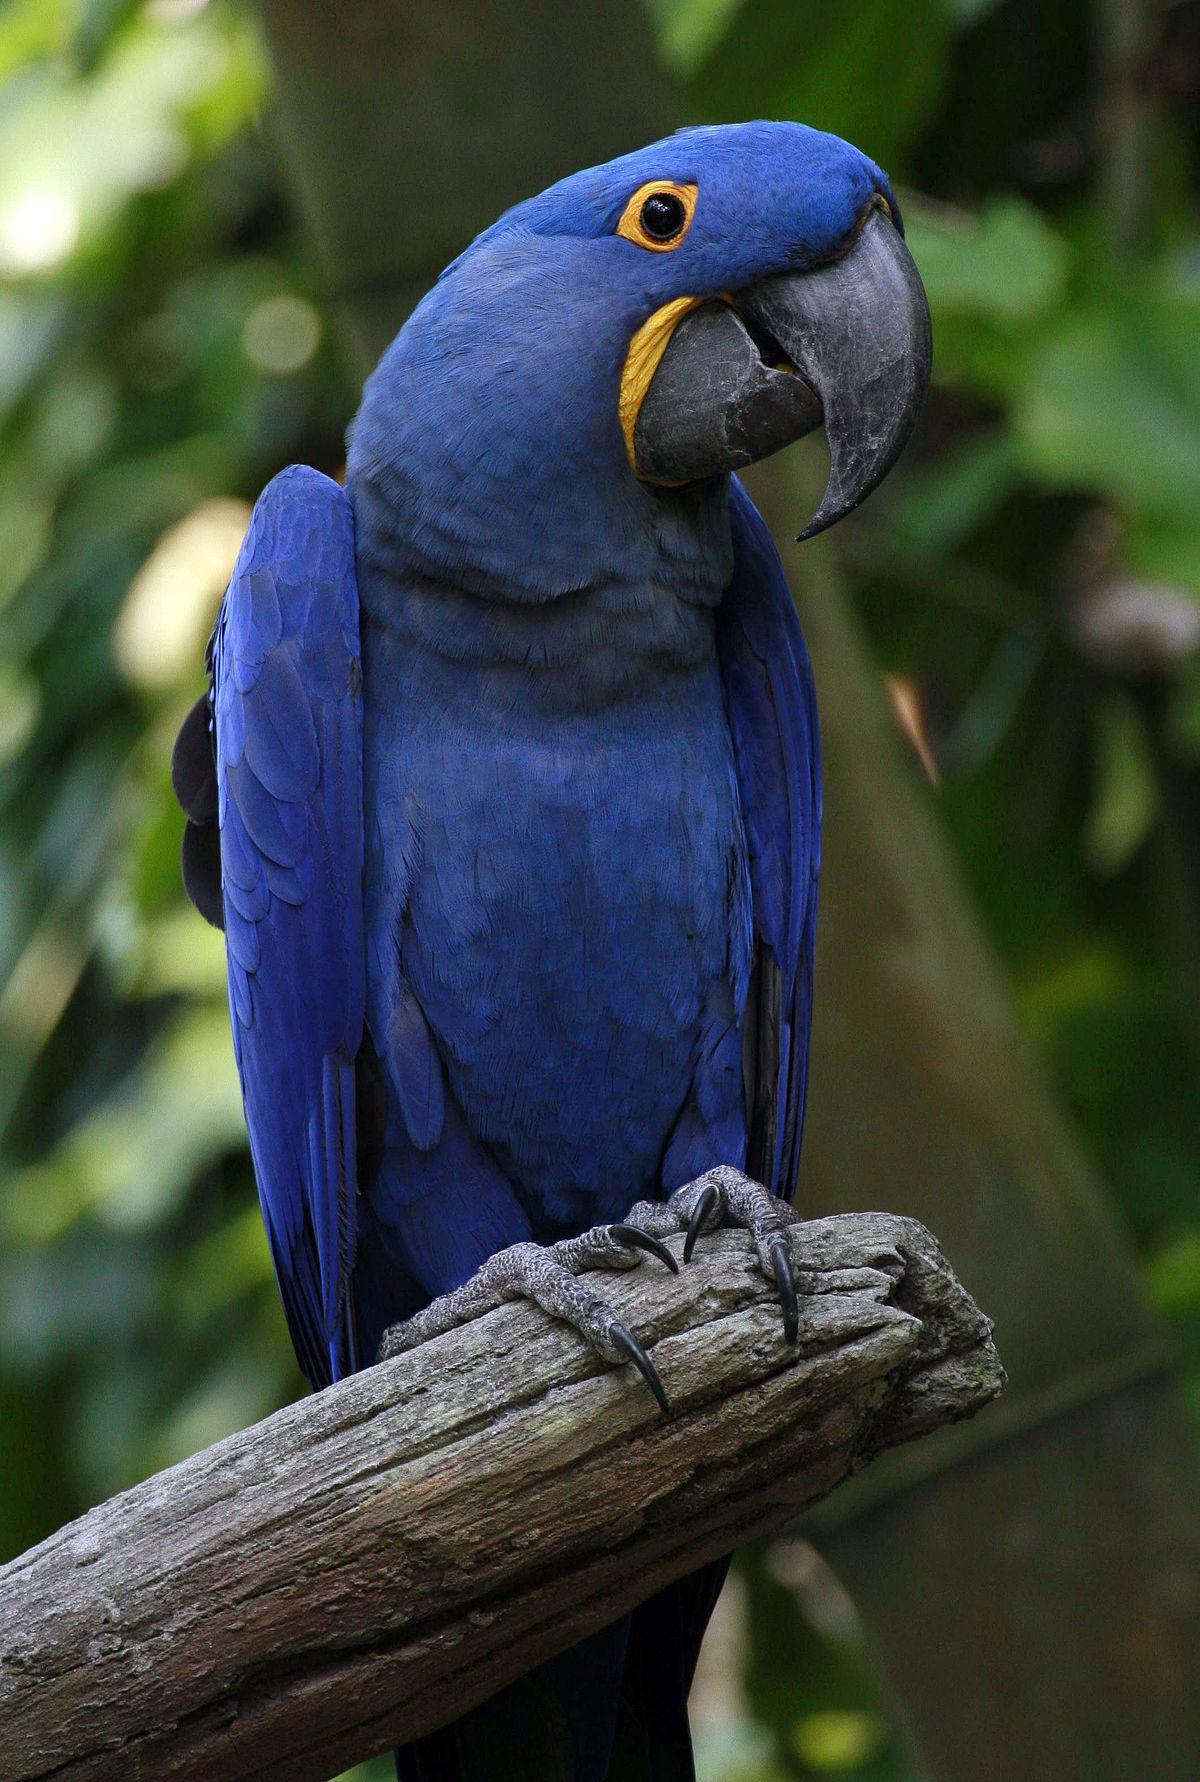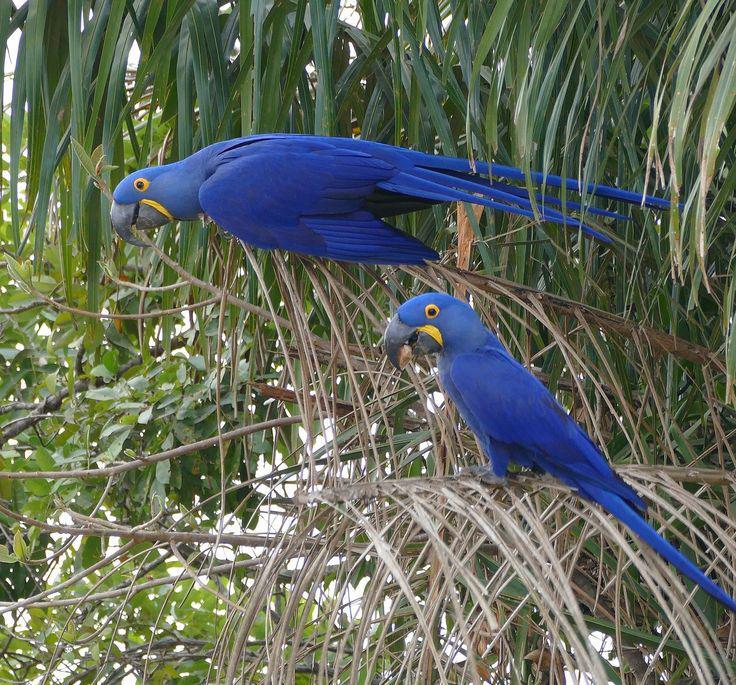The first image is the image on the left, the second image is the image on the right. Examine the images to the left and right. Is the description "The right image contains no more than one blue parrot that is facing towards the left." accurate? Answer yes or no. No. The first image is the image on the left, the second image is the image on the right. Considering the images on both sides, is "An image shows one blue parrot perched on a stub-ended leafless branch." valid? Answer yes or no. Yes. 